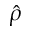Convert formula to latex. <formula><loc_0><loc_0><loc_500><loc_500>\hat { \rho }</formula> 